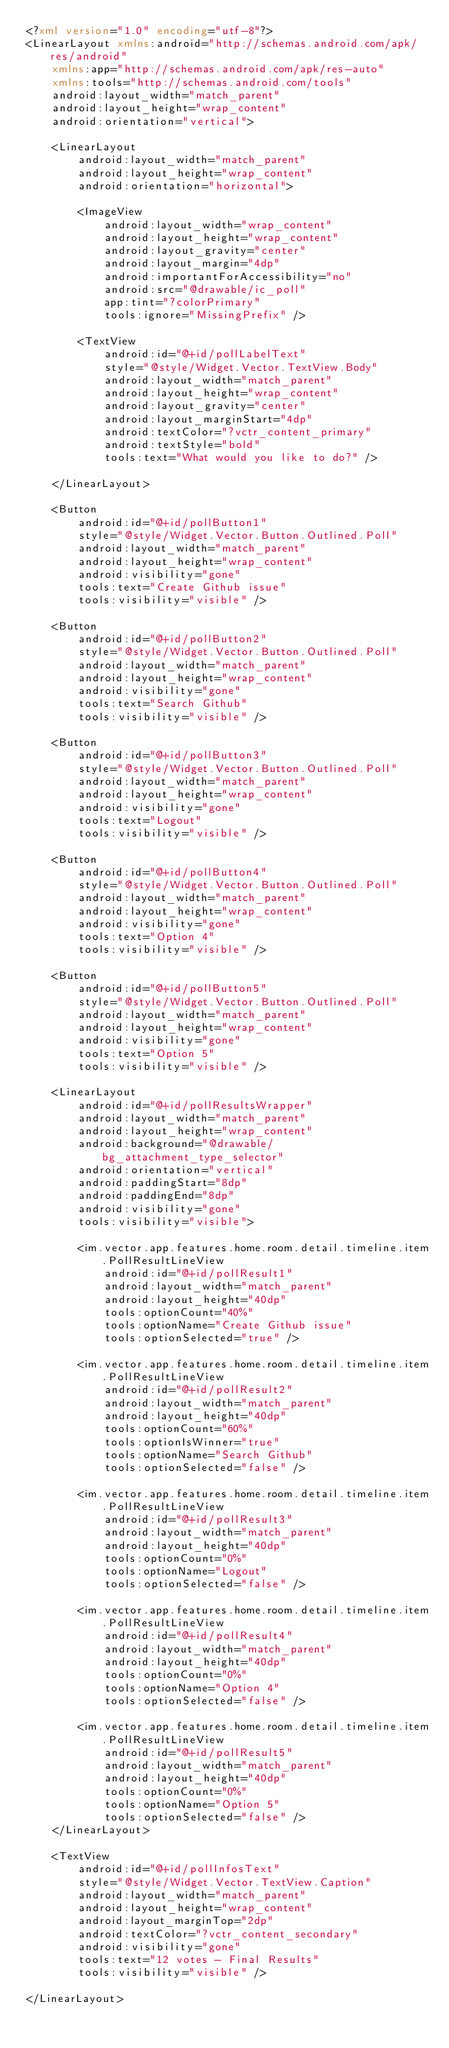<code> <loc_0><loc_0><loc_500><loc_500><_XML_><?xml version="1.0" encoding="utf-8"?>
<LinearLayout xmlns:android="http://schemas.android.com/apk/res/android"
    xmlns:app="http://schemas.android.com/apk/res-auto"
    xmlns:tools="http://schemas.android.com/tools"
    android:layout_width="match_parent"
    android:layout_height="wrap_content"
    android:orientation="vertical">

    <LinearLayout
        android:layout_width="match_parent"
        android:layout_height="wrap_content"
        android:orientation="horizontal">

        <ImageView
            android:layout_width="wrap_content"
            android:layout_height="wrap_content"
            android:layout_gravity="center"
            android:layout_margin="4dp"
            android:importantForAccessibility="no"
            android:src="@drawable/ic_poll"
            app:tint="?colorPrimary"
            tools:ignore="MissingPrefix" />

        <TextView
            android:id="@+id/pollLabelText"
            style="@style/Widget.Vector.TextView.Body"
            android:layout_width="match_parent"
            android:layout_height="wrap_content"
            android:layout_gravity="center"
            android:layout_marginStart="4dp"
            android:textColor="?vctr_content_primary"
            android:textStyle="bold"
            tools:text="What would you like to do?" />

    </LinearLayout>

    <Button
        android:id="@+id/pollButton1"
        style="@style/Widget.Vector.Button.Outlined.Poll"
        android:layout_width="match_parent"
        android:layout_height="wrap_content"
        android:visibility="gone"
        tools:text="Create Github issue"
        tools:visibility="visible" />

    <Button
        android:id="@+id/pollButton2"
        style="@style/Widget.Vector.Button.Outlined.Poll"
        android:layout_width="match_parent"
        android:layout_height="wrap_content"
        android:visibility="gone"
        tools:text="Search Github"
        tools:visibility="visible" />

    <Button
        android:id="@+id/pollButton3"
        style="@style/Widget.Vector.Button.Outlined.Poll"
        android:layout_width="match_parent"
        android:layout_height="wrap_content"
        android:visibility="gone"
        tools:text="Logout"
        tools:visibility="visible" />

    <Button
        android:id="@+id/pollButton4"
        style="@style/Widget.Vector.Button.Outlined.Poll"
        android:layout_width="match_parent"
        android:layout_height="wrap_content"
        android:visibility="gone"
        tools:text="Option 4"
        tools:visibility="visible" />

    <Button
        android:id="@+id/pollButton5"
        style="@style/Widget.Vector.Button.Outlined.Poll"
        android:layout_width="match_parent"
        android:layout_height="wrap_content"
        android:visibility="gone"
        tools:text="Option 5"
        tools:visibility="visible" />

    <LinearLayout
        android:id="@+id/pollResultsWrapper"
        android:layout_width="match_parent"
        android:layout_height="wrap_content"
        android:background="@drawable/bg_attachment_type_selector"
        android:orientation="vertical"
        android:paddingStart="8dp"
        android:paddingEnd="8dp"
        android:visibility="gone"
        tools:visibility="visible">

        <im.vector.app.features.home.room.detail.timeline.item.PollResultLineView
            android:id="@+id/pollResult1"
            android:layout_width="match_parent"
            android:layout_height="40dp"
            tools:optionCount="40%"
            tools:optionName="Create Github issue"
            tools:optionSelected="true" />

        <im.vector.app.features.home.room.detail.timeline.item.PollResultLineView
            android:id="@+id/pollResult2"
            android:layout_width="match_parent"
            android:layout_height="40dp"
            tools:optionCount="60%"
            tools:optionIsWinner="true"
            tools:optionName="Search Github"
            tools:optionSelected="false" />

        <im.vector.app.features.home.room.detail.timeline.item.PollResultLineView
            android:id="@+id/pollResult3"
            android:layout_width="match_parent"
            android:layout_height="40dp"
            tools:optionCount="0%"
            tools:optionName="Logout"
            tools:optionSelected="false" />

        <im.vector.app.features.home.room.detail.timeline.item.PollResultLineView
            android:id="@+id/pollResult4"
            android:layout_width="match_parent"
            android:layout_height="40dp"
            tools:optionCount="0%"
            tools:optionName="Option 4"
            tools:optionSelected="false" />

        <im.vector.app.features.home.room.detail.timeline.item.PollResultLineView
            android:id="@+id/pollResult5"
            android:layout_width="match_parent"
            android:layout_height="40dp"
            tools:optionCount="0%"
            tools:optionName="Option 5"
            tools:optionSelected="false" />
    </LinearLayout>

    <TextView
        android:id="@+id/pollInfosText"
        style="@style/Widget.Vector.TextView.Caption"
        android:layout_width="match_parent"
        android:layout_height="wrap_content"
        android:layout_marginTop="2dp"
        android:textColor="?vctr_content_secondary"
        android:visibility="gone"
        tools:text="12 votes - Final Results"
        tools:visibility="visible" />

</LinearLayout></code> 